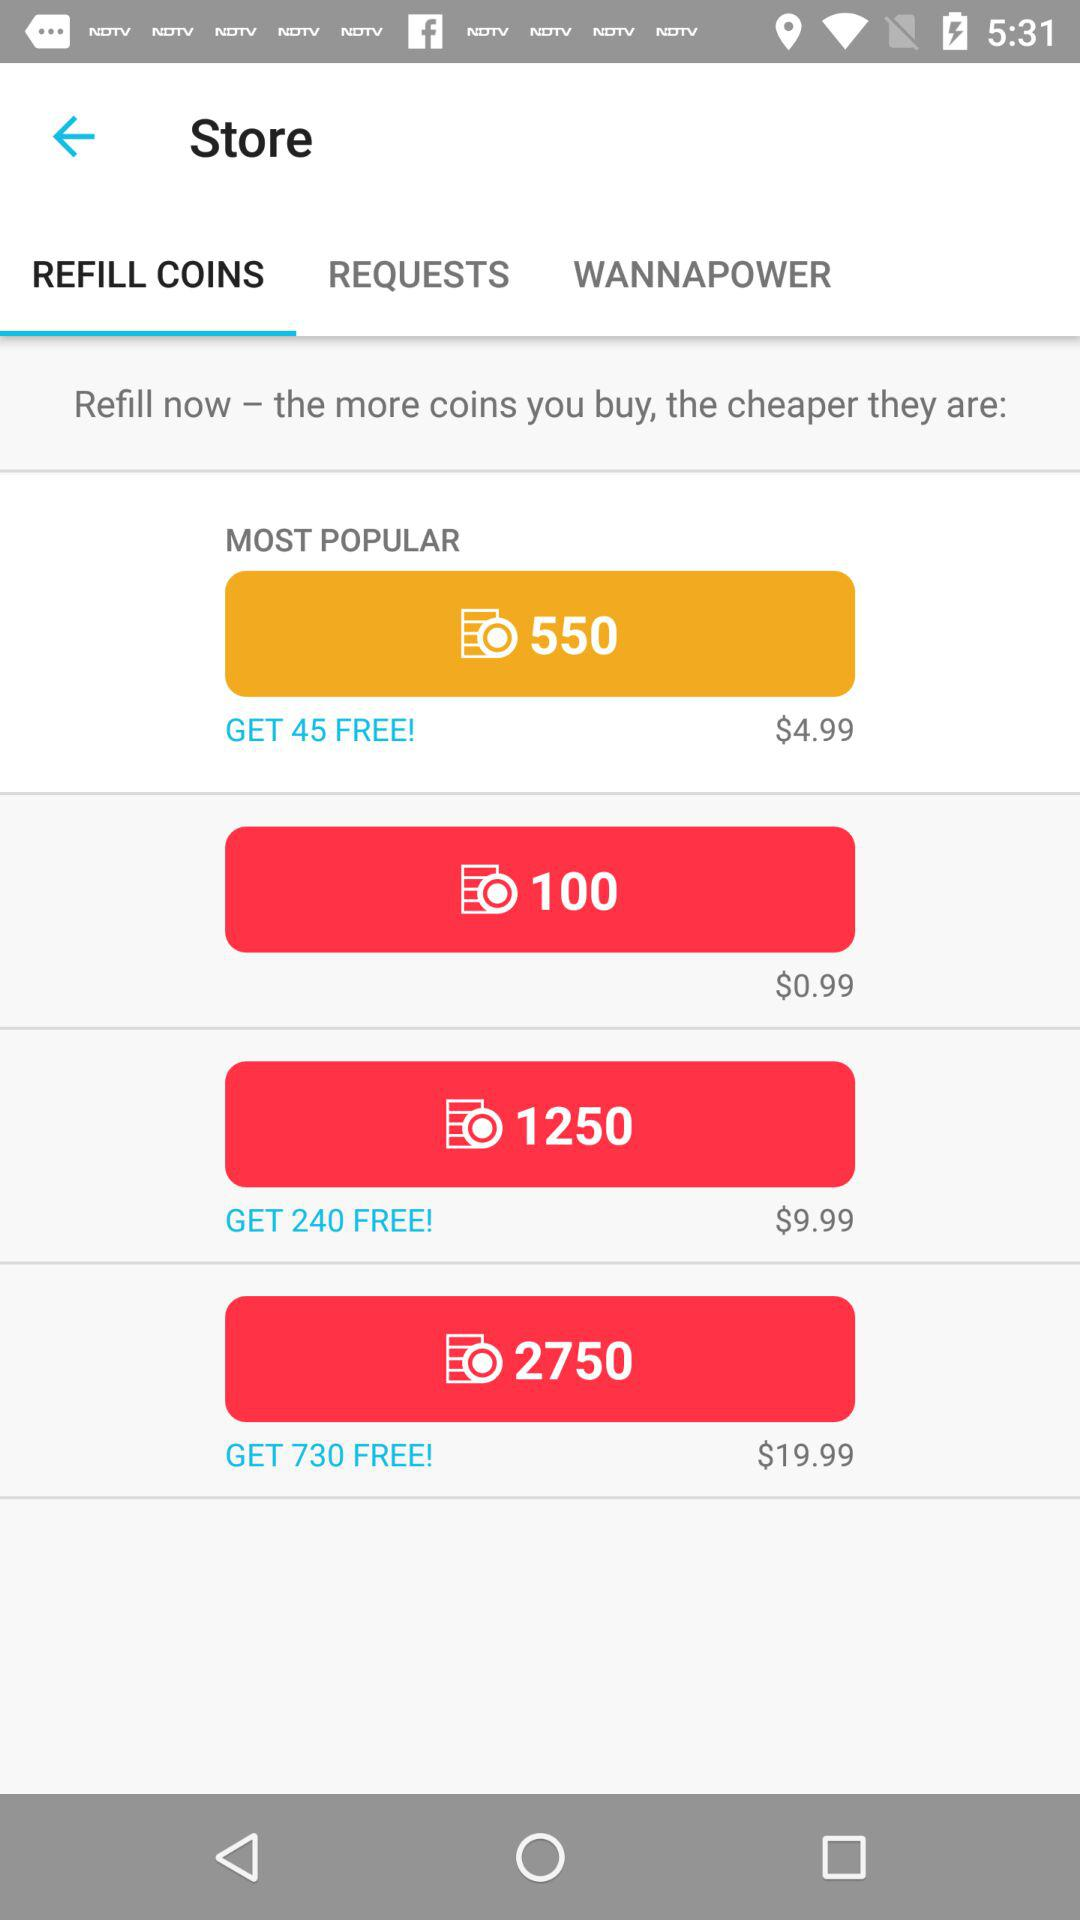How many coins do you get for the cheapest package?
Answer the question using a single word or phrase. 100 